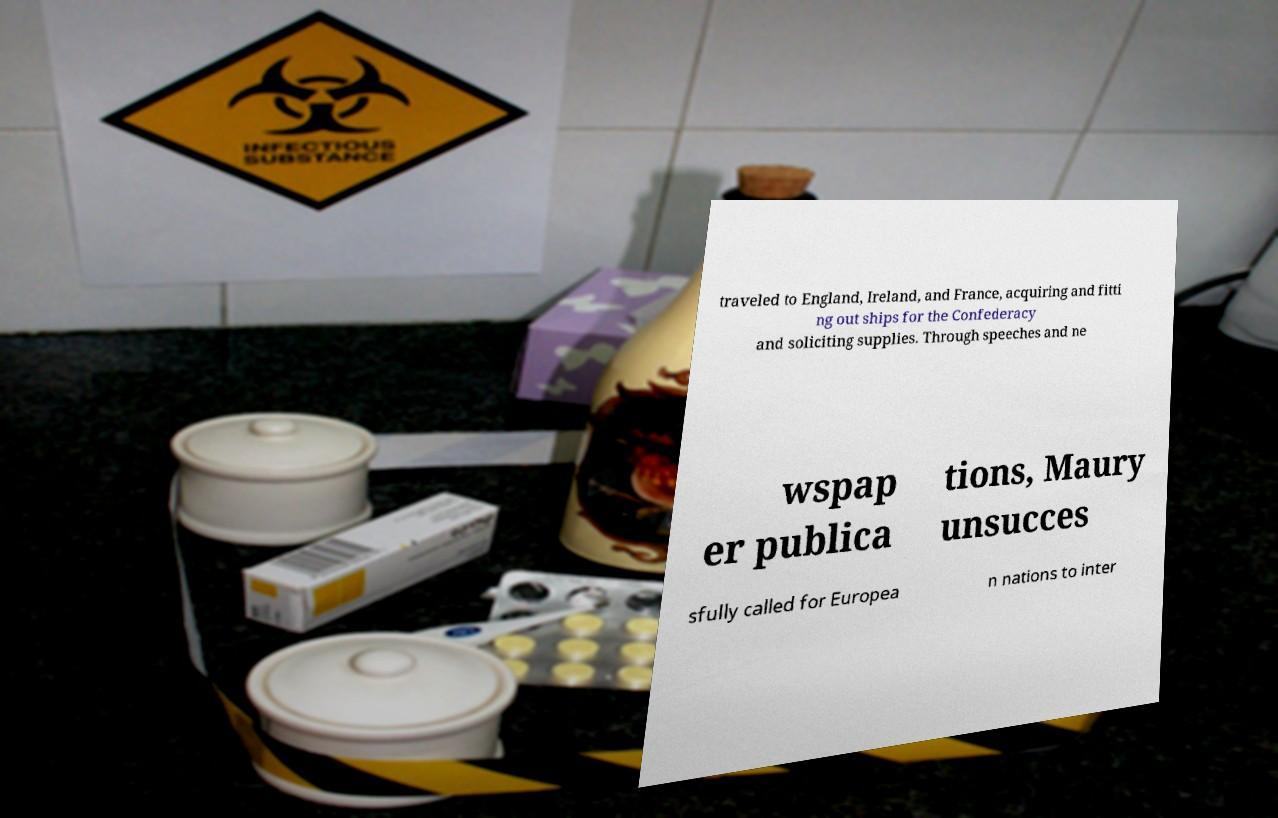Please identify and transcribe the text found in this image. traveled to England, Ireland, and France, acquiring and fitti ng out ships for the Confederacy and soliciting supplies. Through speeches and ne wspap er publica tions, Maury unsucces sfully called for Europea n nations to inter 